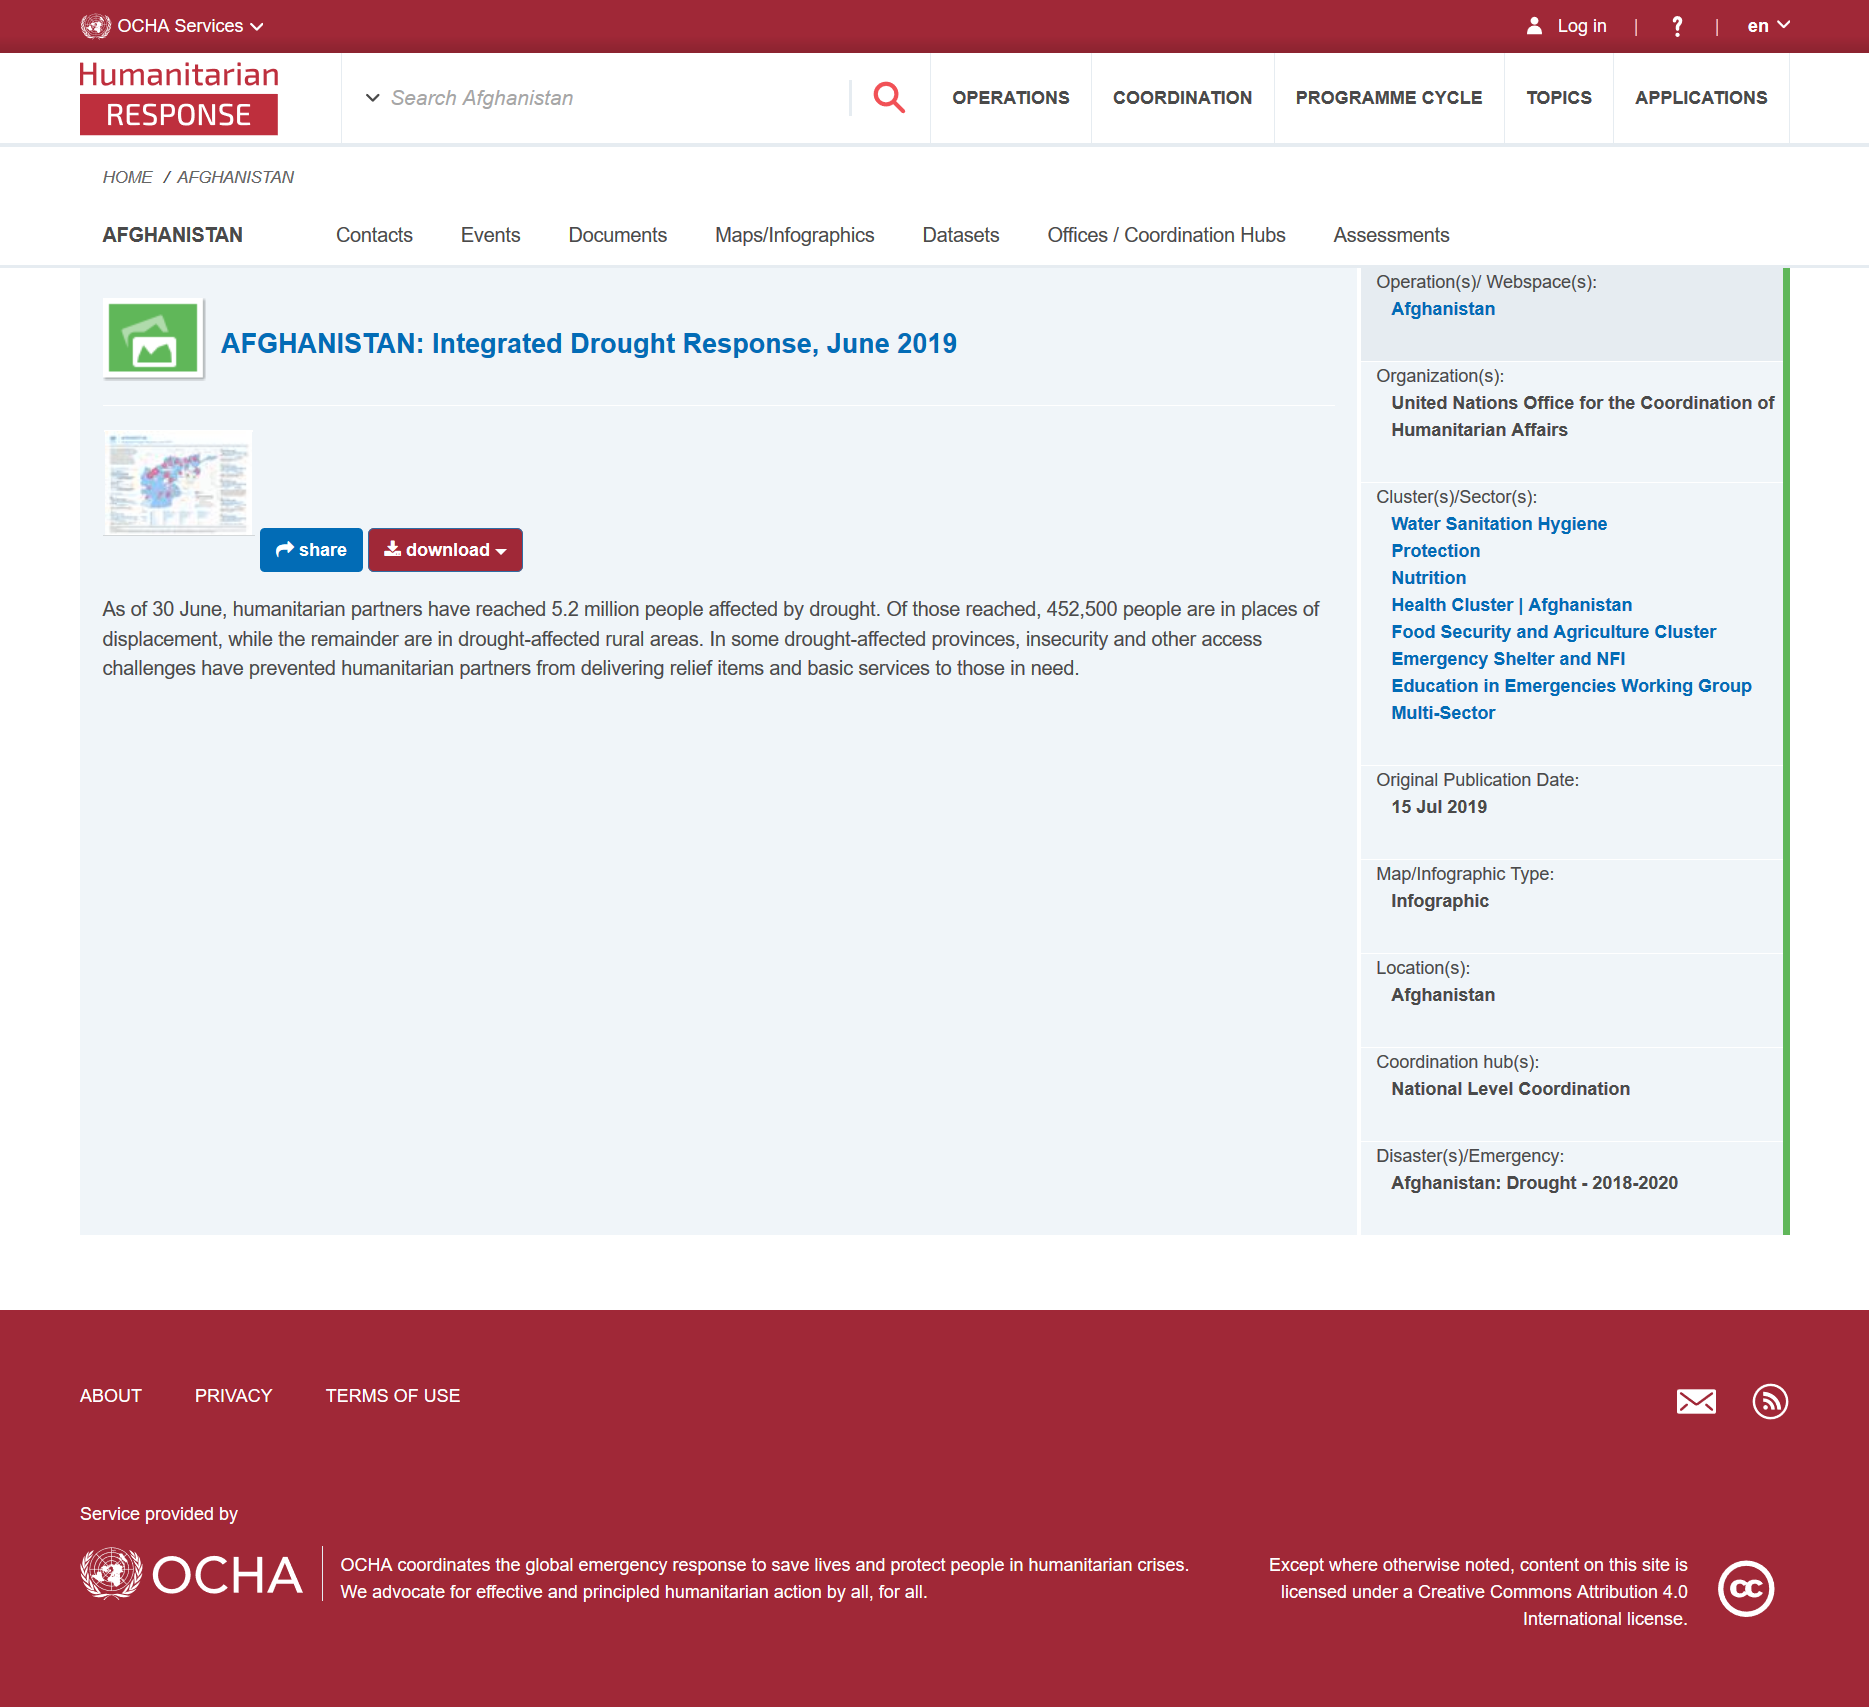Specify some key components in this picture. The action of sharing and downloading can be taken on the included map photo. As of June 30th, our humanitarian partners have reached a total of 5.2 million people who have been affected by drought. 